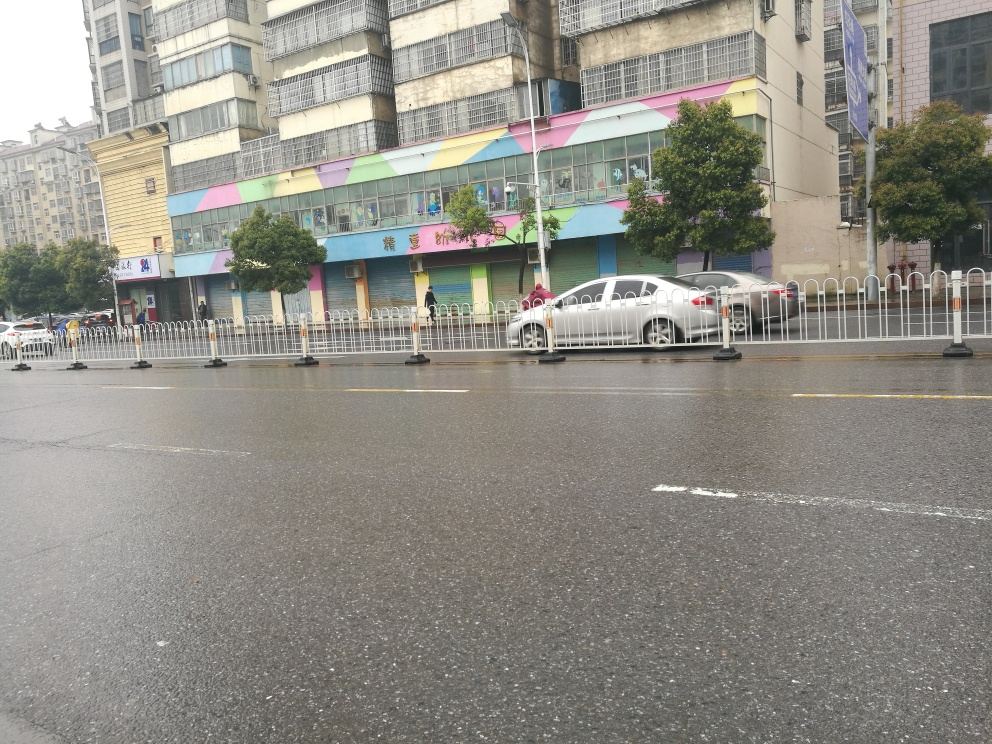What kind of weather does this image suggest? The overcast skies and wet road surface in the image suggest that it has been raining, or at least that there is a likelihood of recent rain. 